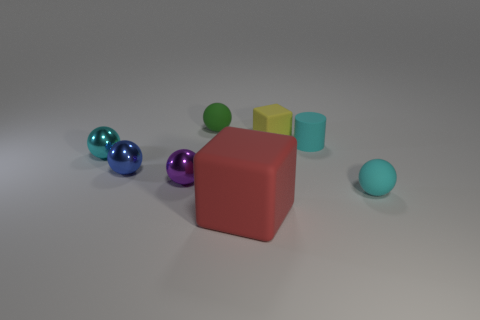Subtract all red cylinders. How many cyan balls are left? 2 Subtract all small cyan rubber balls. How many balls are left? 4 Subtract all blue balls. How many balls are left? 4 Add 2 tiny purple metal balls. How many objects exist? 10 Subtract all green spheres. Subtract all red cylinders. How many spheres are left? 4 Subtract 0 green cubes. How many objects are left? 8 Subtract all balls. How many objects are left? 3 Subtract all gray rubber spheres. Subtract all metallic objects. How many objects are left? 5 Add 2 cyan rubber spheres. How many cyan rubber spheres are left? 3 Add 7 large blue things. How many large blue things exist? 7 